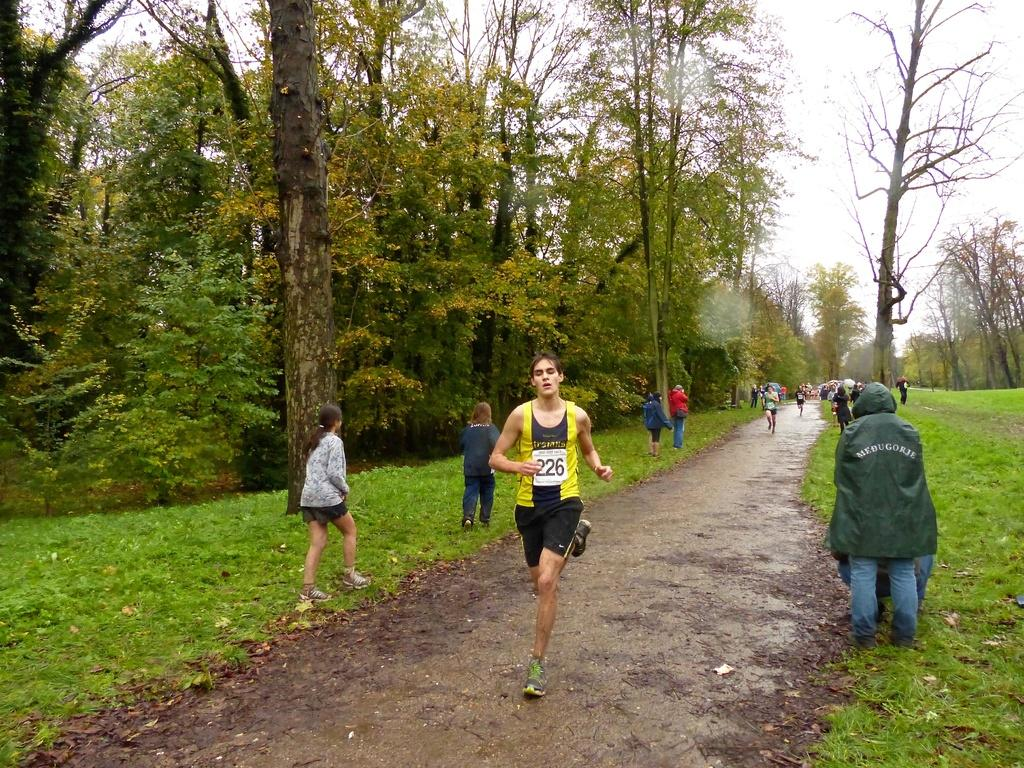What are the people in the middle of the image doing? The people in the middle of the image are running on the ground. What are the people on either side of the path doing? The people on either side of the path are walking. What type of vegetation can be seen in the image? Trees are present in the image. What type of ground surface is visible in the image? Grass is visible in the image. Reasoning: Let's think step by following the steps to produce the conversation. We start by identifying the main activities of the people in the image, which are running and walking. Then, we describe the natural elements present in the image, such as trees and grass. Each question is designed to elicit a specific detail about the image that is known from the provided facts. Absurd Question/Answer: What type of quilt is being used to cover the word in the image? There is no quilt or word present in the image. What type of eggnog is being served to the people in the image? There is no eggnog present in the image. What type of quilt is being used to cover the word in the image? There is no quilt or word present in the image. What type of eggnog is being served to the people in the image? There is no eggnog present in the image. 